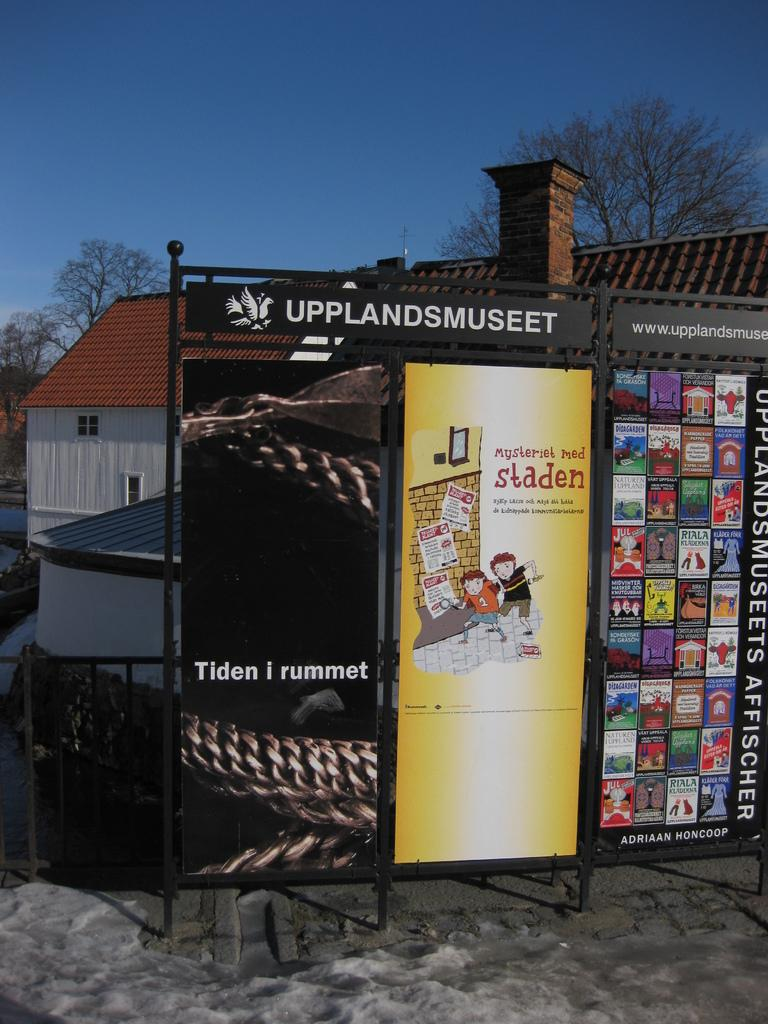Provide a one-sentence caption for the provided image. a metal signboard with adverts saying UPPLANDSMUSEET, Tiden i yummet, staden and lots more. 